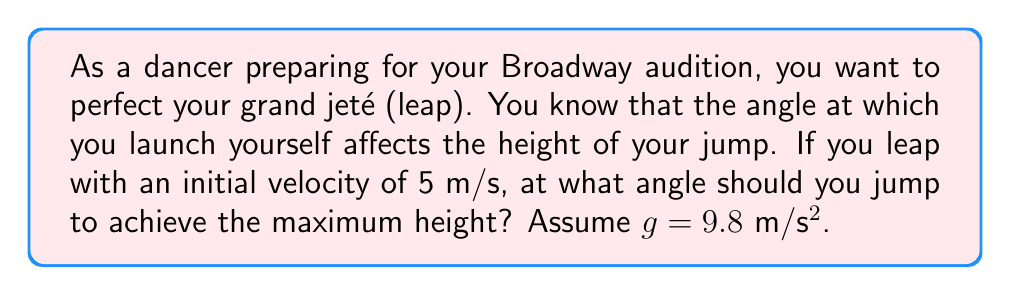Can you answer this question? To solve this problem, we need to use concepts from projectile motion in calculus. The height of a projectile (in this case, your dance leap) is given by the equation:

$$h(t) = v_0 \sin(\theta)t - \frac{1}{2}gt^2$$

Where:
$h(t)$ is the height at time $t$
$v_0$ is the initial velocity
$\theta$ is the angle of launch
$g$ is the acceleration due to gravity

To find the maximum height, we need to find the time when the vertical velocity is zero:

$$\frac{dh}{dt} = v_0 \sin(\theta) - gt = 0$$

Solving for $t$:

$$t = \frac{v_0 \sin(\theta)}{g}$$

Substituting this back into the original equation:

$$h_{max} = v_0 \sin(\theta) \cdot \frac{v_0 \sin(\theta)}{g} - \frac{1}{2}g \cdot (\frac{v_0 \sin(\theta)}{g})^2$$

Simplifying:

$$h_{max} = \frac{v_0^2 \sin^2(\theta)}{2g}$$

To maximize $h_{max}$, we need to maximize $\sin^2(\theta)$. The maximum value of $\sin^2(\theta)$ is 1, which occurs when $\theta = 90°$.

However, this would result in a vertical jump with no forward motion. For a dance leap, we want both height and forward motion. The next best angle that provides both is when $\sin^2(\theta) = \frac{1}{2}$, which occurs when $\theta = 45°$.

Therefore, to achieve the maximum height while still maintaining forward motion in your dance leap, you should jump at a 45° angle.
Answer: The optimal angle for a dance leap to achieve maximum height while maintaining forward motion is 45°. 